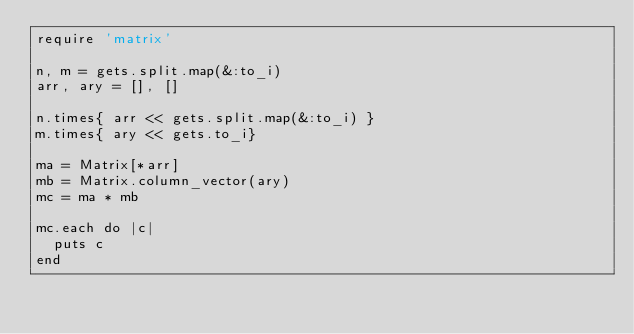Convert code to text. <code><loc_0><loc_0><loc_500><loc_500><_Ruby_>require 'matrix'

n, m = gets.split.map(&:to_i)
arr, ary = [], []

n.times{ arr << gets.split.map(&:to_i) }
m.times{ ary << gets.to_i}

ma = Matrix[*arr]
mb = Matrix.column_vector(ary)
mc = ma * mb

mc.each do |c|
  puts c
end</code> 